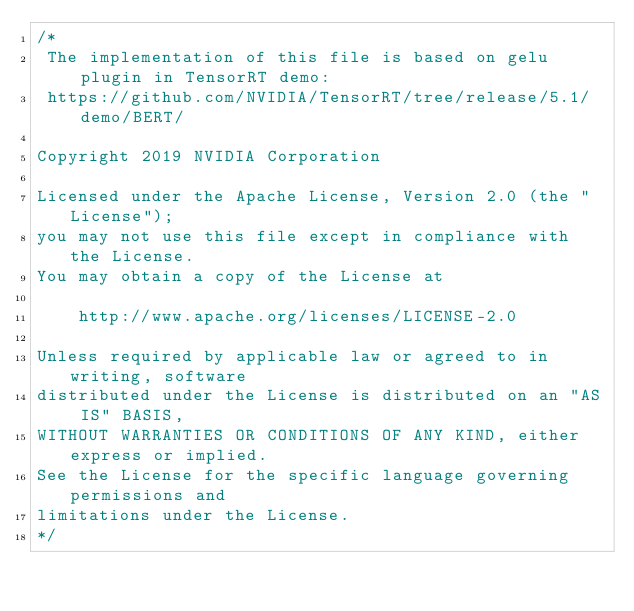Convert code to text. <code><loc_0><loc_0><loc_500><loc_500><_Cuda_>/*
 The implementation of this file is based on gelu plugin in TensorRT demo:
 https://github.com/NVIDIA/TensorRT/tree/release/5.1/demo/BERT/
 
Copyright 2019 NVIDIA Corporation

Licensed under the Apache License, Version 2.0 (the "License");
you may not use this file except in compliance with the License.
You may obtain a copy of the License at

    http://www.apache.org/licenses/LICENSE-2.0

Unless required by applicable law or agreed to in writing, software
distributed under the License is distributed on an "AS IS" BASIS,
WITHOUT WARRANTIES OR CONDITIONS OF ANY KIND, either express or implied.
See the License for the specific language governing permissions and
limitations under the License.
*/
</code> 